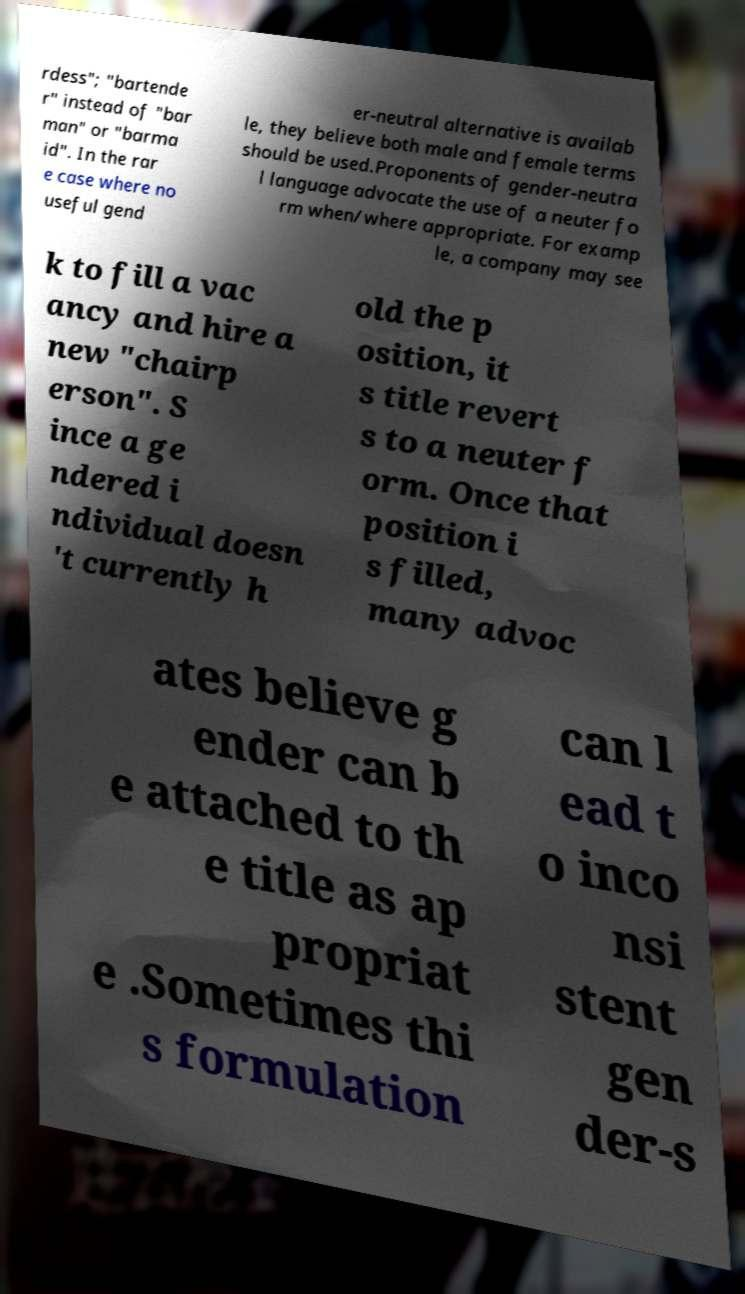For documentation purposes, I need the text within this image transcribed. Could you provide that? rdess"; "bartende r" instead of "bar man" or "barma id". In the rar e case where no useful gend er-neutral alternative is availab le, they believe both male and female terms should be used.Proponents of gender-neutra l language advocate the use of a neuter fo rm when/where appropriate. For examp le, a company may see k to fill a vac ancy and hire a new "chairp erson". S ince a ge ndered i ndividual doesn 't currently h old the p osition, it s title revert s to a neuter f orm. Once that position i s filled, many advoc ates believe g ender can b e attached to th e title as ap propriat e .Sometimes thi s formulation can l ead t o inco nsi stent gen der-s 